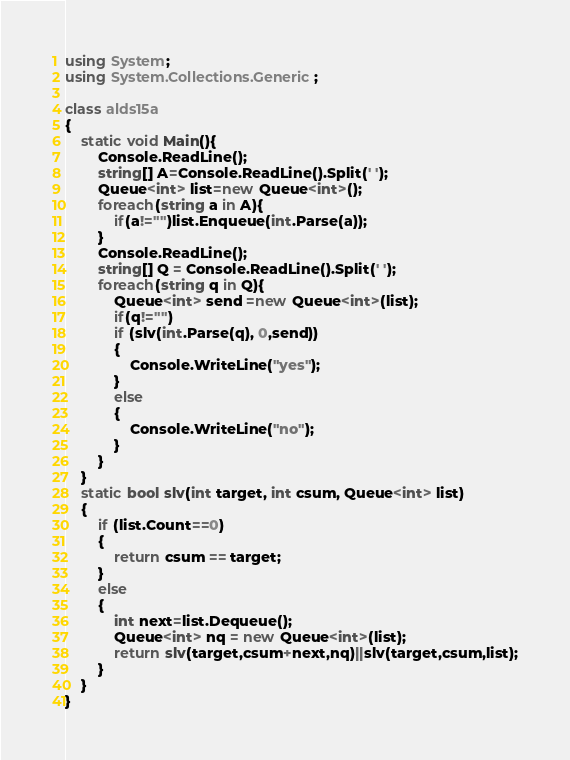Convert code to text. <code><loc_0><loc_0><loc_500><loc_500><_C#_>using System;
using System.Collections.Generic;

class alds15a
{
    static void Main(){
        Console.ReadLine();
        string[] A=Console.ReadLine().Split(' ');
        Queue<int> list=new Queue<int>();
        foreach(string a in A){
            if(a!="")list.Enqueue(int.Parse(a));
        }
        Console.ReadLine();
        string[] Q = Console.ReadLine().Split(' ');
        foreach(string q in Q){
            Queue<int> send =new Queue<int>(list);
            if(q!="")
            if (slv(int.Parse(q), 0,send))
            {
                Console.WriteLine("yes");
            }
            else
            {
                Console.WriteLine("no");
            }
        }
    }
    static bool slv(int target, int csum, Queue<int> list)
    {
        if (list.Count==0)
        {
            return csum == target;
        }
        else
        {
            int next=list.Dequeue();
            Queue<int> nq = new Queue<int>(list);
            return slv(target,csum+next,nq)||slv(target,csum,list);
        }
    }
}</code> 